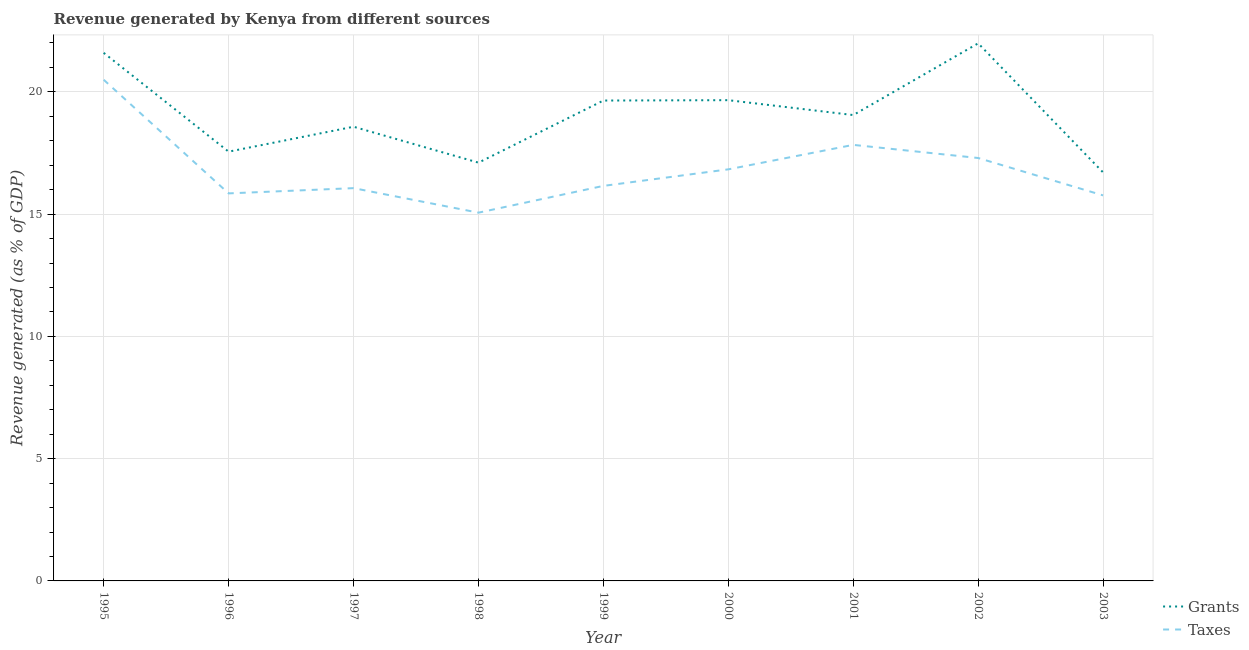What is the revenue generated by taxes in 2002?
Offer a very short reply. 17.29. Across all years, what is the maximum revenue generated by grants?
Keep it short and to the point. 21.98. Across all years, what is the minimum revenue generated by grants?
Offer a terse response. 16.7. What is the total revenue generated by grants in the graph?
Give a very brief answer. 171.87. What is the difference between the revenue generated by taxes in 1999 and that in 2000?
Keep it short and to the point. -0.68. What is the difference between the revenue generated by grants in 2002 and the revenue generated by taxes in 2000?
Offer a very short reply. 5.15. What is the average revenue generated by grants per year?
Offer a very short reply. 19.1. In the year 2003, what is the difference between the revenue generated by grants and revenue generated by taxes?
Make the answer very short. 0.94. What is the ratio of the revenue generated by taxes in 2000 to that in 2001?
Provide a succinct answer. 0.94. What is the difference between the highest and the second highest revenue generated by taxes?
Provide a succinct answer. 2.66. What is the difference between the highest and the lowest revenue generated by grants?
Your response must be concise. 5.28. In how many years, is the revenue generated by grants greater than the average revenue generated by grants taken over all years?
Provide a short and direct response. 4. Is the sum of the revenue generated by taxes in 2001 and 2003 greater than the maximum revenue generated by grants across all years?
Provide a succinct answer. Yes. Does the revenue generated by grants monotonically increase over the years?
Keep it short and to the point. No. Does the graph contain any zero values?
Make the answer very short. No. Does the graph contain grids?
Provide a succinct answer. Yes. Where does the legend appear in the graph?
Provide a succinct answer. Bottom right. How many legend labels are there?
Ensure brevity in your answer.  2. What is the title of the graph?
Give a very brief answer. Revenue generated by Kenya from different sources. Does "International Visitors" appear as one of the legend labels in the graph?
Offer a very short reply. No. What is the label or title of the Y-axis?
Make the answer very short. Revenue generated (as % of GDP). What is the Revenue generated (as % of GDP) of Grants in 1995?
Your response must be concise. 21.59. What is the Revenue generated (as % of GDP) in Taxes in 1995?
Your answer should be very brief. 20.49. What is the Revenue generated (as % of GDP) of Grants in 1996?
Make the answer very short. 17.55. What is the Revenue generated (as % of GDP) of Taxes in 1996?
Your answer should be very brief. 15.85. What is the Revenue generated (as % of GDP) of Grants in 1997?
Ensure brevity in your answer.  18.57. What is the Revenue generated (as % of GDP) of Taxes in 1997?
Provide a short and direct response. 16.06. What is the Revenue generated (as % of GDP) in Grants in 1998?
Your answer should be very brief. 17.1. What is the Revenue generated (as % of GDP) of Taxes in 1998?
Your answer should be very brief. 15.06. What is the Revenue generated (as % of GDP) in Grants in 1999?
Your response must be concise. 19.64. What is the Revenue generated (as % of GDP) of Taxes in 1999?
Give a very brief answer. 16.15. What is the Revenue generated (as % of GDP) of Grants in 2000?
Your answer should be very brief. 19.66. What is the Revenue generated (as % of GDP) in Taxes in 2000?
Make the answer very short. 16.83. What is the Revenue generated (as % of GDP) of Grants in 2001?
Offer a terse response. 19.05. What is the Revenue generated (as % of GDP) of Taxes in 2001?
Provide a short and direct response. 17.83. What is the Revenue generated (as % of GDP) in Grants in 2002?
Ensure brevity in your answer.  21.98. What is the Revenue generated (as % of GDP) of Taxes in 2002?
Make the answer very short. 17.29. What is the Revenue generated (as % of GDP) in Grants in 2003?
Provide a succinct answer. 16.7. What is the Revenue generated (as % of GDP) of Taxes in 2003?
Offer a very short reply. 15.77. Across all years, what is the maximum Revenue generated (as % of GDP) of Grants?
Give a very brief answer. 21.98. Across all years, what is the maximum Revenue generated (as % of GDP) of Taxes?
Your answer should be compact. 20.49. Across all years, what is the minimum Revenue generated (as % of GDP) in Grants?
Offer a very short reply. 16.7. Across all years, what is the minimum Revenue generated (as % of GDP) in Taxes?
Keep it short and to the point. 15.06. What is the total Revenue generated (as % of GDP) in Grants in the graph?
Keep it short and to the point. 171.87. What is the total Revenue generated (as % of GDP) in Taxes in the graph?
Provide a succinct answer. 151.34. What is the difference between the Revenue generated (as % of GDP) of Grants in 1995 and that in 1996?
Offer a terse response. 4.04. What is the difference between the Revenue generated (as % of GDP) in Taxes in 1995 and that in 1996?
Provide a succinct answer. 4.65. What is the difference between the Revenue generated (as % of GDP) of Grants in 1995 and that in 1997?
Give a very brief answer. 3.02. What is the difference between the Revenue generated (as % of GDP) in Taxes in 1995 and that in 1997?
Your answer should be very brief. 4.43. What is the difference between the Revenue generated (as % of GDP) in Grants in 1995 and that in 1998?
Offer a terse response. 4.49. What is the difference between the Revenue generated (as % of GDP) of Taxes in 1995 and that in 1998?
Your answer should be very brief. 5.43. What is the difference between the Revenue generated (as % of GDP) of Grants in 1995 and that in 1999?
Your answer should be very brief. 1.95. What is the difference between the Revenue generated (as % of GDP) in Taxes in 1995 and that in 1999?
Your answer should be very brief. 4.34. What is the difference between the Revenue generated (as % of GDP) in Grants in 1995 and that in 2000?
Provide a succinct answer. 1.94. What is the difference between the Revenue generated (as % of GDP) of Taxes in 1995 and that in 2000?
Provide a succinct answer. 3.66. What is the difference between the Revenue generated (as % of GDP) of Grants in 1995 and that in 2001?
Ensure brevity in your answer.  2.54. What is the difference between the Revenue generated (as % of GDP) in Taxes in 1995 and that in 2001?
Your answer should be very brief. 2.66. What is the difference between the Revenue generated (as % of GDP) in Grants in 1995 and that in 2002?
Give a very brief answer. -0.39. What is the difference between the Revenue generated (as % of GDP) of Taxes in 1995 and that in 2002?
Your answer should be very brief. 3.2. What is the difference between the Revenue generated (as % of GDP) in Grants in 1995 and that in 2003?
Your answer should be compact. 4.89. What is the difference between the Revenue generated (as % of GDP) of Taxes in 1995 and that in 2003?
Provide a short and direct response. 4.73. What is the difference between the Revenue generated (as % of GDP) in Grants in 1996 and that in 1997?
Give a very brief answer. -1.02. What is the difference between the Revenue generated (as % of GDP) of Taxes in 1996 and that in 1997?
Keep it short and to the point. -0.21. What is the difference between the Revenue generated (as % of GDP) in Grants in 1996 and that in 1998?
Provide a short and direct response. 0.45. What is the difference between the Revenue generated (as % of GDP) in Taxes in 1996 and that in 1998?
Keep it short and to the point. 0.79. What is the difference between the Revenue generated (as % of GDP) in Grants in 1996 and that in 1999?
Your answer should be compact. -2.09. What is the difference between the Revenue generated (as % of GDP) in Taxes in 1996 and that in 1999?
Provide a short and direct response. -0.31. What is the difference between the Revenue generated (as % of GDP) of Grants in 1996 and that in 2000?
Provide a short and direct response. -2.11. What is the difference between the Revenue generated (as % of GDP) of Taxes in 1996 and that in 2000?
Your response must be concise. -0.98. What is the difference between the Revenue generated (as % of GDP) of Grants in 1996 and that in 2001?
Ensure brevity in your answer.  -1.5. What is the difference between the Revenue generated (as % of GDP) in Taxes in 1996 and that in 2001?
Give a very brief answer. -1.98. What is the difference between the Revenue generated (as % of GDP) in Grants in 1996 and that in 2002?
Ensure brevity in your answer.  -4.43. What is the difference between the Revenue generated (as % of GDP) in Taxes in 1996 and that in 2002?
Make the answer very short. -1.45. What is the difference between the Revenue generated (as % of GDP) of Grants in 1996 and that in 2003?
Provide a succinct answer. 0.85. What is the difference between the Revenue generated (as % of GDP) in Taxes in 1996 and that in 2003?
Your answer should be very brief. 0.08. What is the difference between the Revenue generated (as % of GDP) of Grants in 1997 and that in 1998?
Provide a succinct answer. 1.47. What is the difference between the Revenue generated (as % of GDP) in Grants in 1997 and that in 1999?
Give a very brief answer. -1.07. What is the difference between the Revenue generated (as % of GDP) in Taxes in 1997 and that in 1999?
Offer a terse response. -0.09. What is the difference between the Revenue generated (as % of GDP) of Grants in 1997 and that in 2000?
Provide a succinct answer. -1.09. What is the difference between the Revenue generated (as % of GDP) of Taxes in 1997 and that in 2000?
Offer a terse response. -0.77. What is the difference between the Revenue generated (as % of GDP) of Grants in 1997 and that in 2001?
Ensure brevity in your answer.  -0.48. What is the difference between the Revenue generated (as % of GDP) of Taxes in 1997 and that in 2001?
Make the answer very short. -1.77. What is the difference between the Revenue generated (as % of GDP) in Grants in 1997 and that in 2002?
Make the answer very short. -3.41. What is the difference between the Revenue generated (as % of GDP) of Taxes in 1997 and that in 2002?
Ensure brevity in your answer.  -1.23. What is the difference between the Revenue generated (as % of GDP) of Grants in 1997 and that in 2003?
Provide a short and direct response. 1.87. What is the difference between the Revenue generated (as % of GDP) of Taxes in 1997 and that in 2003?
Offer a very short reply. 0.3. What is the difference between the Revenue generated (as % of GDP) in Grants in 1998 and that in 1999?
Ensure brevity in your answer.  -2.54. What is the difference between the Revenue generated (as % of GDP) in Taxes in 1998 and that in 1999?
Keep it short and to the point. -1.09. What is the difference between the Revenue generated (as % of GDP) in Grants in 1998 and that in 2000?
Your answer should be very brief. -2.55. What is the difference between the Revenue generated (as % of GDP) in Taxes in 1998 and that in 2000?
Make the answer very short. -1.77. What is the difference between the Revenue generated (as % of GDP) in Grants in 1998 and that in 2001?
Provide a short and direct response. -1.95. What is the difference between the Revenue generated (as % of GDP) of Taxes in 1998 and that in 2001?
Provide a short and direct response. -2.77. What is the difference between the Revenue generated (as % of GDP) in Grants in 1998 and that in 2002?
Ensure brevity in your answer.  -4.88. What is the difference between the Revenue generated (as % of GDP) of Taxes in 1998 and that in 2002?
Give a very brief answer. -2.24. What is the difference between the Revenue generated (as % of GDP) of Grants in 1998 and that in 2003?
Give a very brief answer. 0.4. What is the difference between the Revenue generated (as % of GDP) in Taxes in 1998 and that in 2003?
Offer a terse response. -0.71. What is the difference between the Revenue generated (as % of GDP) in Grants in 1999 and that in 2000?
Provide a short and direct response. -0.02. What is the difference between the Revenue generated (as % of GDP) in Taxes in 1999 and that in 2000?
Provide a short and direct response. -0.68. What is the difference between the Revenue generated (as % of GDP) of Grants in 1999 and that in 2001?
Offer a very short reply. 0.59. What is the difference between the Revenue generated (as % of GDP) in Taxes in 1999 and that in 2001?
Provide a succinct answer. -1.68. What is the difference between the Revenue generated (as % of GDP) of Grants in 1999 and that in 2002?
Your response must be concise. -2.34. What is the difference between the Revenue generated (as % of GDP) in Taxes in 1999 and that in 2002?
Keep it short and to the point. -1.14. What is the difference between the Revenue generated (as % of GDP) in Grants in 1999 and that in 2003?
Offer a terse response. 2.94. What is the difference between the Revenue generated (as % of GDP) in Taxes in 1999 and that in 2003?
Provide a short and direct response. 0.39. What is the difference between the Revenue generated (as % of GDP) in Grants in 2000 and that in 2001?
Offer a terse response. 0.61. What is the difference between the Revenue generated (as % of GDP) in Taxes in 2000 and that in 2001?
Offer a very short reply. -1. What is the difference between the Revenue generated (as % of GDP) of Grants in 2000 and that in 2002?
Your response must be concise. -2.32. What is the difference between the Revenue generated (as % of GDP) in Taxes in 2000 and that in 2002?
Ensure brevity in your answer.  -0.46. What is the difference between the Revenue generated (as % of GDP) of Grants in 2000 and that in 2003?
Make the answer very short. 2.95. What is the difference between the Revenue generated (as % of GDP) of Taxes in 2000 and that in 2003?
Your response must be concise. 1.07. What is the difference between the Revenue generated (as % of GDP) of Grants in 2001 and that in 2002?
Provide a succinct answer. -2.93. What is the difference between the Revenue generated (as % of GDP) of Taxes in 2001 and that in 2002?
Your answer should be compact. 0.54. What is the difference between the Revenue generated (as % of GDP) of Grants in 2001 and that in 2003?
Provide a short and direct response. 2.35. What is the difference between the Revenue generated (as % of GDP) of Taxes in 2001 and that in 2003?
Your answer should be compact. 2.07. What is the difference between the Revenue generated (as % of GDP) of Grants in 2002 and that in 2003?
Make the answer very short. 5.28. What is the difference between the Revenue generated (as % of GDP) in Taxes in 2002 and that in 2003?
Provide a succinct answer. 1.53. What is the difference between the Revenue generated (as % of GDP) of Grants in 1995 and the Revenue generated (as % of GDP) of Taxes in 1996?
Provide a short and direct response. 5.75. What is the difference between the Revenue generated (as % of GDP) of Grants in 1995 and the Revenue generated (as % of GDP) of Taxes in 1997?
Give a very brief answer. 5.53. What is the difference between the Revenue generated (as % of GDP) of Grants in 1995 and the Revenue generated (as % of GDP) of Taxes in 1998?
Offer a very short reply. 6.54. What is the difference between the Revenue generated (as % of GDP) in Grants in 1995 and the Revenue generated (as % of GDP) in Taxes in 1999?
Provide a succinct answer. 5.44. What is the difference between the Revenue generated (as % of GDP) of Grants in 1995 and the Revenue generated (as % of GDP) of Taxes in 2000?
Your answer should be very brief. 4.76. What is the difference between the Revenue generated (as % of GDP) in Grants in 1995 and the Revenue generated (as % of GDP) in Taxes in 2001?
Make the answer very short. 3.76. What is the difference between the Revenue generated (as % of GDP) of Grants in 1995 and the Revenue generated (as % of GDP) of Taxes in 2002?
Provide a succinct answer. 4.3. What is the difference between the Revenue generated (as % of GDP) in Grants in 1995 and the Revenue generated (as % of GDP) in Taxes in 2003?
Offer a terse response. 5.83. What is the difference between the Revenue generated (as % of GDP) in Grants in 1996 and the Revenue generated (as % of GDP) in Taxes in 1997?
Your answer should be very brief. 1.49. What is the difference between the Revenue generated (as % of GDP) of Grants in 1996 and the Revenue generated (as % of GDP) of Taxes in 1998?
Make the answer very short. 2.49. What is the difference between the Revenue generated (as % of GDP) in Grants in 1996 and the Revenue generated (as % of GDP) in Taxes in 1999?
Your answer should be compact. 1.4. What is the difference between the Revenue generated (as % of GDP) in Grants in 1996 and the Revenue generated (as % of GDP) in Taxes in 2000?
Make the answer very short. 0.72. What is the difference between the Revenue generated (as % of GDP) in Grants in 1996 and the Revenue generated (as % of GDP) in Taxes in 2001?
Offer a very short reply. -0.28. What is the difference between the Revenue generated (as % of GDP) in Grants in 1996 and the Revenue generated (as % of GDP) in Taxes in 2002?
Provide a short and direct response. 0.26. What is the difference between the Revenue generated (as % of GDP) of Grants in 1996 and the Revenue generated (as % of GDP) of Taxes in 2003?
Your answer should be very brief. 1.79. What is the difference between the Revenue generated (as % of GDP) in Grants in 1997 and the Revenue generated (as % of GDP) in Taxes in 1998?
Your answer should be very brief. 3.51. What is the difference between the Revenue generated (as % of GDP) in Grants in 1997 and the Revenue generated (as % of GDP) in Taxes in 1999?
Ensure brevity in your answer.  2.42. What is the difference between the Revenue generated (as % of GDP) in Grants in 1997 and the Revenue generated (as % of GDP) in Taxes in 2000?
Ensure brevity in your answer.  1.74. What is the difference between the Revenue generated (as % of GDP) of Grants in 1997 and the Revenue generated (as % of GDP) of Taxes in 2001?
Provide a succinct answer. 0.74. What is the difference between the Revenue generated (as % of GDP) of Grants in 1997 and the Revenue generated (as % of GDP) of Taxes in 2002?
Keep it short and to the point. 1.28. What is the difference between the Revenue generated (as % of GDP) of Grants in 1997 and the Revenue generated (as % of GDP) of Taxes in 2003?
Your answer should be compact. 2.81. What is the difference between the Revenue generated (as % of GDP) in Grants in 1998 and the Revenue generated (as % of GDP) in Taxes in 1999?
Your response must be concise. 0.95. What is the difference between the Revenue generated (as % of GDP) in Grants in 1998 and the Revenue generated (as % of GDP) in Taxes in 2000?
Provide a succinct answer. 0.27. What is the difference between the Revenue generated (as % of GDP) of Grants in 1998 and the Revenue generated (as % of GDP) of Taxes in 2001?
Give a very brief answer. -0.73. What is the difference between the Revenue generated (as % of GDP) in Grants in 1998 and the Revenue generated (as % of GDP) in Taxes in 2002?
Give a very brief answer. -0.19. What is the difference between the Revenue generated (as % of GDP) in Grants in 1998 and the Revenue generated (as % of GDP) in Taxes in 2003?
Offer a very short reply. 1.34. What is the difference between the Revenue generated (as % of GDP) of Grants in 1999 and the Revenue generated (as % of GDP) of Taxes in 2000?
Your response must be concise. 2.81. What is the difference between the Revenue generated (as % of GDP) in Grants in 1999 and the Revenue generated (as % of GDP) in Taxes in 2001?
Your answer should be very brief. 1.81. What is the difference between the Revenue generated (as % of GDP) in Grants in 1999 and the Revenue generated (as % of GDP) in Taxes in 2002?
Give a very brief answer. 2.35. What is the difference between the Revenue generated (as % of GDP) of Grants in 1999 and the Revenue generated (as % of GDP) of Taxes in 2003?
Offer a terse response. 3.88. What is the difference between the Revenue generated (as % of GDP) of Grants in 2000 and the Revenue generated (as % of GDP) of Taxes in 2001?
Offer a terse response. 1.83. What is the difference between the Revenue generated (as % of GDP) in Grants in 2000 and the Revenue generated (as % of GDP) in Taxes in 2002?
Offer a very short reply. 2.37. What is the difference between the Revenue generated (as % of GDP) in Grants in 2000 and the Revenue generated (as % of GDP) in Taxes in 2003?
Offer a terse response. 3.89. What is the difference between the Revenue generated (as % of GDP) of Grants in 2001 and the Revenue generated (as % of GDP) of Taxes in 2002?
Your answer should be compact. 1.76. What is the difference between the Revenue generated (as % of GDP) in Grants in 2001 and the Revenue generated (as % of GDP) in Taxes in 2003?
Make the answer very short. 3.29. What is the difference between the Revenue generated (as % of GDP) in Grants in 2002 and the Revenue generated (as % of GDP) in Taxes in 2003?
Offer a very short reply. 6.22. What is the average Revenue generated (as % of GDP) in Grants per year?
Your response must be concise. 19.1. What is the average Revenue generated (as % of GDP) in Taxes per year?
Ensure brevity in your answer.  16.82. In the year 1995, what is the difference between the Revenue generated (as % of GDP) of Grants and Revenue generated (as % of GDP) of Taxes?
Make the answer very short. 1.1. In the year 1996, what is the difference between the Revenue generated (as % of GDP) of Grants and Revenue generated (as % of GDP) of Taxes?
Your answer should be very brief. 1.71. In the year 1997, what is the difference between the Revenue generated (as % of GDP) of Grants and Revenue generated (as % of GDP) of Taxes?
Your response must be concise. 2.51. In the year 1998, what is the difference between the Revenue generated (as % of GDP) of Grants and Revenue generated (as % of GDP) of Taxes?
Provide a short and direct response. 2.05. In the year 1999, what is the difference between the Revenue generated (as % of GDP) of Grants and Revenue generated (as % of GDP) of Taxes?
Offer a very short reply. 3.49. In the year 2000, what is the difference between the Revenue generated (as % of GDP) of Grants and Revenue generated (as % of GDP) of Taxes?
Offer a terse response. 2.83. In the year 2001, what is the difference between the Revenue generated (as % of GDP) of Grants and Revenue generated (as % of GDP) of Taxes?
Your answer should be compact. 1.22. In the year 2002, what is the difference between the Revenue generated (as % of GDP) of Grants and Revenue generated (as % of GDP) of Taxes?
Provide a short and direct response. 4.69. In the year 2003, what is the difference between the Revenue generated (as % of GDP) of Grants and Revenue generated (as % of GDP) of Taxes?
Your answer should be very brief. 0.94. What is the ratio of the Revenue generated (as % of GDP) of Grants in 1995 to that in 1996?
Ensure brevity in your answer.  1.23. What is the ratio of the Revenue generated (as % of GDP) of Taxes in 1995 to that in 1996?
Your answer should be very brief. 1.29. What is the ratio of the Revenue generated (as % of GDP) of Grants in 1995 to that in 1997?
Give a very brief answer. 1.16. What is the ratio of the Revenue generated (as % of GDP) in Taxes in 1995 to that in 1997?
Provide a short and direct response. 1.28. What is the ratio of the Revenue generated (as % of GDP) in Grants in 1995 to that in 1998?
Offer a very short reply. 1.26. What is the ratio of the Revenue generated (as % of GDP) in Taxes in 1995 to that in 1998?
Provide a succinct answer. 1.36. What is the ratio of the Revenue generated (as % of GDP) of Grants in 1995 to that in 1999?
Give a very brief answer. 1.1. What is the ratio of the Revenue generated (as % of GDP) in Taxes in 1995 to that in 1999?
Provide a succinct answer. 1.27. What is the ratio of the Revenue generated (as % of GDP) in Grants in 1995 to that in 2000?
Keep it short and to the point. 1.1. What is the ratio of the Revenue generated (as % of GDP) in Taxes in 1995 to that in 2000?
Your answer should be very brief. 1.22. What is the ratio of the Revenue generated (as % of GDP) in Grants in 1995 to that in 2001?
Your answer should be very brief. 1.13. What is the ratio of the Revenue generated (as % of GDP) of Taxes in 1995 to that in 2001?
Make the answer very short. 1.15. What is the ratio of the Revenue generated (as % of GDP) of Grants in 1995 to that in 2002?
Provide a short and direct response. 0.98. What is the ratio of the Revenue generated (as % of GDP) of Taxes in 1995 to that in 2002?
Give a very brief answer. 1.19. What is the ratio of the Revenue generated (as % of GDP) of Grants in 1995 to that in 2003?
Your answer should be compact. 1.29. What is the ratio of the Revenue generated (as % of GDP) of Taxes in 1995 to that in 2003?
Offer a very short reply. 1.3. What is the ratio of the Revenue generated (as % of GDP) of Grants in 1996 to that in 1997?
Your answer should be very brief. 0.95. What is the ratio of the Revenue generated (as % of GDP) in Taxes in 1996 to that in 1997?
Your response must be concise. 0.99. What is the ratio of the Revenue generated (as % of GDP) of Grants in 1996 to that in 1998?
Offer a terse response. 1.03. What is the ratio of the Revenue generated (as % of GDP) in Taxes in 1996 to that in 1998?
Provide a short and direct response. 1.05. What is the ratio of the Revenue generated (as % of GDP) of Grants in 1996 to that in 1999?
Your answer should be compact. 0.89. What is the ratio of the Revenue generated (as % of GDP) in Grants in 1996 to that in 2000?
Make the answer very short. 0.89. What is the ratio of the Revenue generated (as % of GDP) in Taxes in 1996 to that in 2000?
Your answer should be compact. 0.94. What is the ratio of the Revenue generated (as % of GDP) of Grants in 1996 to that in 2001?
Your response must be concise. 0.92. What is the ratio of the Revenue generated (as % of GDP) in Taxes in 1996 to that in 2001?
Ensure brevity in your answer.  0.89. What is the ratio of the Revenue generated (as % of GDP) in Grants in 1996 to that in 2002?
Offer a terse response. 0.8. What is the ratio of the Revenue generated (as % of GDP) in Taxes in 1996 to that in 2002?
Provide a short and direct response. 0.92. What is the ratio of the Revenue generated (as % of GDP) in Grants in 1996 to that in 2003?
Offer a very short reply. 1.05. What is the ratio of the Revenue generated (as % of GDP) of Grants in 1997 to that in 1998?
Offer a terse response. 1.09. What is the ratio of the Revenue generated (as % of GDP) in Taxes in 1997 to that in 1998?
Give a very brief answer. 1.07. What is the ratio of the Revenue generated (as % of GDP) in Grants in 1997 to that in 1999?
Your response must be concise. 0.95. What is the ratio of the Revenue generated (as % of GDP) in Taxes in 1997 to that in 1999?
Offer a terse response. 0.99. What is the ratio of the Revenue generated (as % of GDP) of Grants in 1997 to that in 2000?
Provide a succinct answer. 0.94. What is the ratio of the Revenue generated (as % of GDP) of Taxes in 1997 to that in 2000?
Offer a very short reply. 0.95. What is the ratio of the Revenue generated (as % of GDP) of Grants in 1997 to that in 2001?
Offer a very short reply. 0.97. What is the ratio of the Revenue generated (as % of GDP) in Taxes in 1997 to that in 2001?
Your answer should be compact. 0.9. What is the ratio of the Revenue generated (as % of GDP) in Grants in 1997 to that in 2002?
Provide a short and direct response. 0.84. What is the ratio of the Revenue generated (as % of GDP) in Taxes in 1997 to that in 2002?
Offer a terse response. 0.93. What is the ratio of the Revenue generated (as % of GDP) in Grants in 1997 to that in 2003?
Provide a short and direct response. 1.11. What is the ratio of the Revenue generated (as % of GDP) in Taxes in 1997 to that in 2003?
Provide a succinct answer. 1.02. What is the ratio of the Revenue generated (as % of GDP) in Grants in 1998 to that in 1999?
Your response must be concise. 0.87. What is the ratio of the Revenue generated (as % of GDP) in Taxes in 1998 to that in 1999?
Offer a terse response. 0.93. What is the ratio of the Revenue generated (as % of GDP) in Grants in 1998 to that in 2000?
Provide a short and direct response. 0.87. What is the ratio of the Revenue generated (as % of GDP) of Taxes in 1998 to that in 2000?
Offer a terse response. 0.89. What is the ratio of the Revenue generated (as % of GDP) in Grants in 1998 to that in 2001?
Your answer should be compact. 0.9. What is the ratio of the Revenue generated (as % of GDP) of Taxes in 1998 to that in 2001?
Make the answer very short. 0.84. What is the ratio of the Revenue generated (as % of GDP) in Grants in 1998 to that in 2002?
Your answer should be compact. 0.78. What is the ratio of the Revenue generated (as % of GDP) in Taxes in 1998 to that in 2002?
Your answer should be compact. 0.87. What is the ratio of the Revenue generated (as % of GDP) in Grants in 1998 to that in 2003?
Offer a terse response. 1.02. What is the ratio of the Revenue generated (as % of GDP) of Taxes in 1998 to that in 2003?
Your answer should be very brief. 0.96. What is the ratio of the Revenue generated (as % of GDP) in Taxes in 1999 to that in 2000?
Provide a succinct answer. 0.96. What is the ratio of the Revenue generated (as % of GDP) of Grants in 1999 to that in 2001?
Give a very brief answer. 1.03. What is the ratio of the Revenue generated (as % of GDP) of Taxes in 1999 to that in 2001?
Make the answer very short. 0.91. What is the ratio of the Revenue generated (as % of GDP) in Grants in 1999 to that in 2002?
Provide a succinct answer. 0.89. What is the ratio of the Revenue generated (as % of GDP) in Taxes in 1999 to that in 2002?
Offer a very short reply. 0.93. What is the ratio of the Revenue generated (as % of GDP) of Grants in 1999 to that in 2003?
Provide a succinct answer. 1.18. What is the ratio of the Revenue generated (as % of GDP) of Taxes in 1999 to that in 2003?
Make the answer very short. 1.02. What is the ratio of the Revenue generated (as % of GDP) in Grants in 2000 to that in 2001?
Provide a succinct answer. 1.03. What is the ratio of the Revenue generated (as % of GDP) of Taxes in 2000 to that in 2001?
Keep it short and to the point. 0.94. What is the ratio of the Revenue generated (as % of GDP) in Grants in 2000 to that in 2002?
Make the answer very short. 0.89. What is the ratio of the Revenue generated (as % of GDP) in Taxes in 2000 to that in 2002?
Provide a short and direct response. 0.97. What is the ratio of the Revenue generated (as % of GDP) of Grants in 2000 to that in 2003?
Offer a terse response. 1.18. What is the ratio of the Revenue generated (as % of GDP) of Taxes in 2000 to that in 2003?
Provide a succinct answer. 1.07. What is the ratio of the Revenue generated (as % of GDP) of Grants in 2001 to that in 2002?
Your response must be concise. 0.87. What is the ratio of the Revenue generated (as % of GDP) in Taxes in 2001 to that in 2002?
Make the answer very short. 1.03. What is the ratio of the Revenue generated (as % of GDP) of Grants in 2001 to that in 2003?
Your answer should be very brief. 1.14. What is the ratio of the Revenue generated (as % of GDP) of Taxes in 2001 to that in 2003?
Your response must be concise. 1.13. What is the ratio of the Revenue generated (as % of GDP) in Grants in 2002 to that in 2003?
Your answer should be very brief. 1.32. What is the ratio of the Revenue generated (as % of GDP) of Taxes in 2002 to that in 2003?
Your answer should be very brief. 1.1. What is the difference between the highest and the second highest Revenue generated (as % of GDP) in Grants?
Provide a succinct answer. 0.39. What is the difference between the highest and the second highest Revenue generated (as % of GDP) of Taxes?
Keep it short and to the point. 2.66. What is the difference between the highest and the lowest Revenue generated (as % of GDP) of Grants?
Provide a short and direct response. 5.28. What is the difference between the highest and the lowest Revenue generated (as % of GDP) in Taxes?
Your answer should be compact. 5.43. 